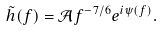<formula> <loc_0><loc_0><loc_500><loc_500>\tilde { h } ( f ) = \mathcal { A } f ^ { - 7 / 6 } e ^ { i \psi ( f ) } .</formula> 